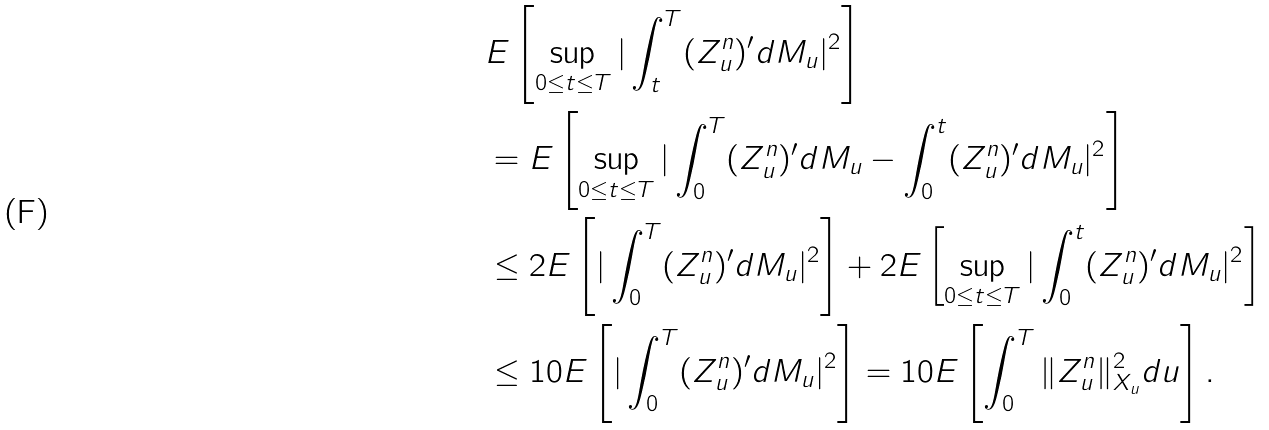Convert formula to latex. <formula><loc_0><loc_0><loc_500><loc_500>& E \left [ \sup _ { 0 \leq t \leq T } | \int _ { t } ^ { T } ( Z _ { u } ^ { n } ) ^ { \prime } d M _ { u } | ^ { 2 } \right ] \\ & = E \left [ \sup _ { 0 \leq t \leq T } | \int _ { 0 } ^ { T } ( Z _ { u } ^ { n } ) ^ { \prime } d M _ { u } - \int _ { 0 } ^ { t } ( Z _ { u } ^ { n } ) ^ { \prime } d M _ { u } | ^ { 2 } \right ] \\ & \leq 2 E \left [ | \int _ { 0 } ^ { T } ( Z _ { u } ^ { n } ) ^ { \prime } d M _ { u } | ^ { 2 } \right ] + 2 E \left [ \sup _ { 0 \leq t \leq T } | \int _ { 0 } ^ { t } ( Z _ { u } ^ { n } ) ^ { \prime } d M _ { u } | ^ { 2 } \right ] \\ & \leq 1 0 E \left [ | \int _ { 0 } ^ { T } ( Z _ { u } ^ { n } ) ^ { \prime } d M _ { u } | ^ { 2 } \right ] = 1 0 E \left [ \int _ { 0 } ^ { T } \| Z _ { u } ^ { n } \| ^ { 2 } _ { X _ { u } } d u \right ] .</formula> 